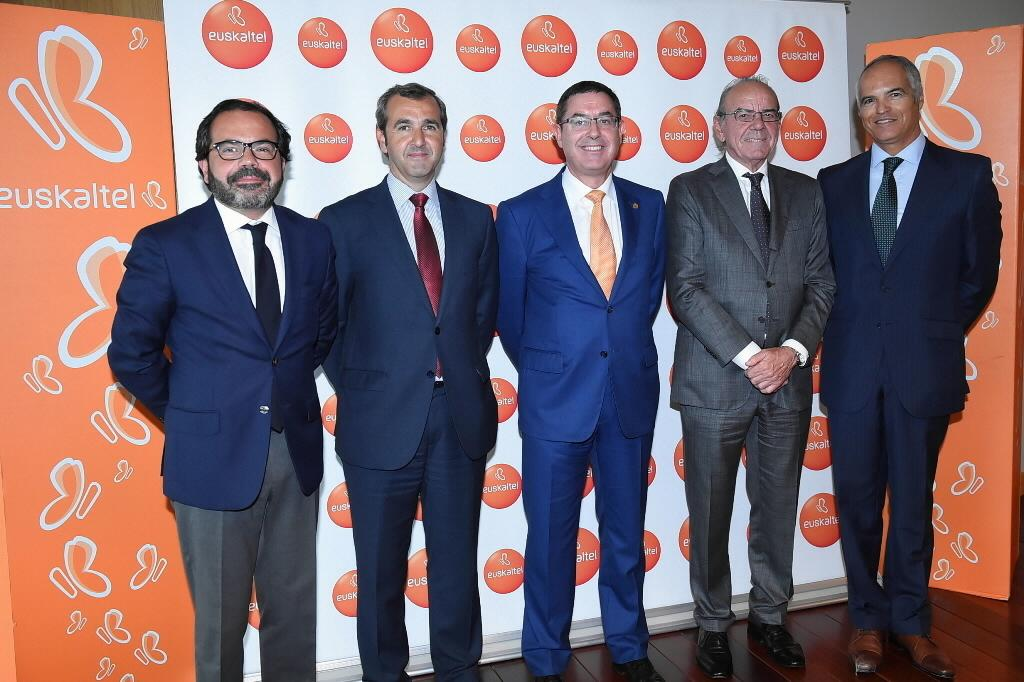What is happening in the image involving the group of men? The men are standing and posing for a photo in the image. What can be seen in the background of the image? There are banners visible in the background of the image. What information is displayed on the banners? The banners contain the name of an organisation. What type of pig can be seen in the image? There is no pig present in the image. What are the men eating for lunch in the image? The image does not show the men eating lunch, so it cannot be determined from the image. 